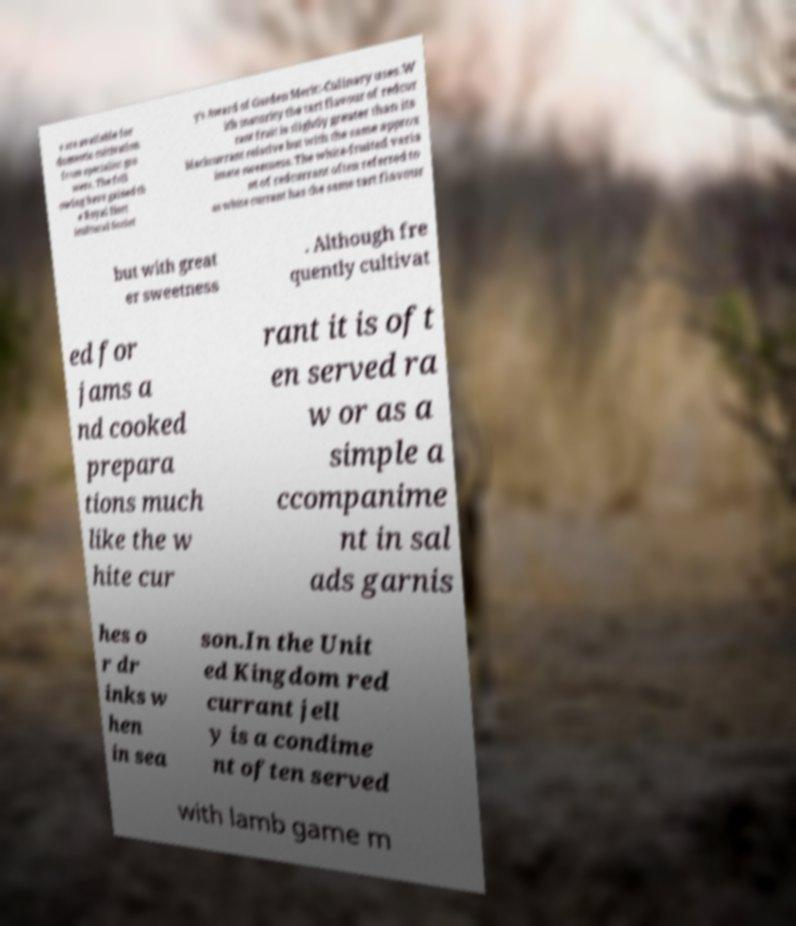Can you read and provide the text displayed in the image?This photo seems to have some interesting text. Can you extract and type it out for me? s are available for domestic cultivation from specialist gro wers. The foll owing have gained th e Royal Hort icultural Societ y’s Award of Garden Merit:-Culinary uses.W ith maturity the tart flavour of redcur rant fruit is slightly greater than its blackcurrant relative but with the same approx imate sweetness. The white-fruited varia nt of redcurrant often referred to as white currant has the same tart flavour but with great er sweetness . Although fre quently cultivat ed for jams a nd cooked prepara tions much like the w hite cur rant it is oft en served ra w or as a simple a ccompanime nt in sal ads garnis hes o r dr inks w hen in sea son.In the Unit ed Kingdom red currant jell y is a condime nt often served with lamb game m 